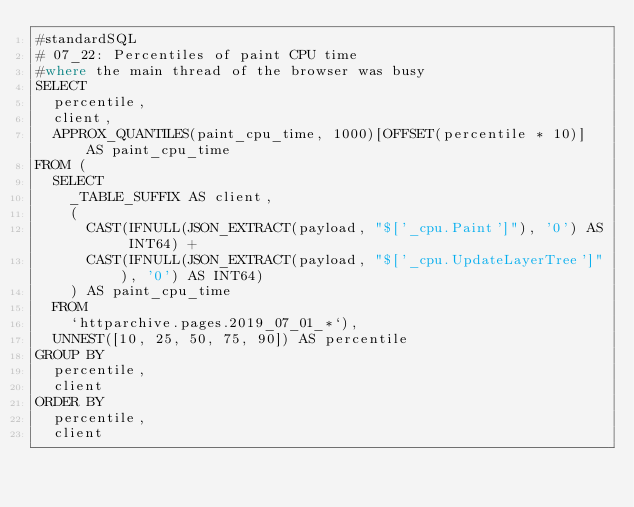Convert code to text. <code><loc_0><loc_0><loc_500><loc_500><_SQL_>#standardSQL
# 07_22: Percentiles of paint CPU time
#where the main thread of the browser was busy
SELECT
  percentile,
  client,
  APPROX_QUANTILES(paint_cpu_time, 1000)[OFFSET(percentile * 10)] AS paint_cpu_time
FROM (
  SELECT
    _TABLE_SUFFIX AS client,
    (
      CAST(IFNULL(JSON_EXTRACT(payload, "$['_cpu.Paint']"), '0') AS INT64) +
      CAST(IFNULL(JSON_EXTRACT(payload, "$['_cpu.UpdateLayerTree']"), '0') AS INT64)
    ) AS paint_cpu_time
  FROM
    `httparchive.pages.2019_07_01_*`),
  UNNEST([10, 25, 50, 75, 90]) AS percentile
GROUP BY
  percentile,
  client
ORDER BY
  percentile,
  client
</code> 